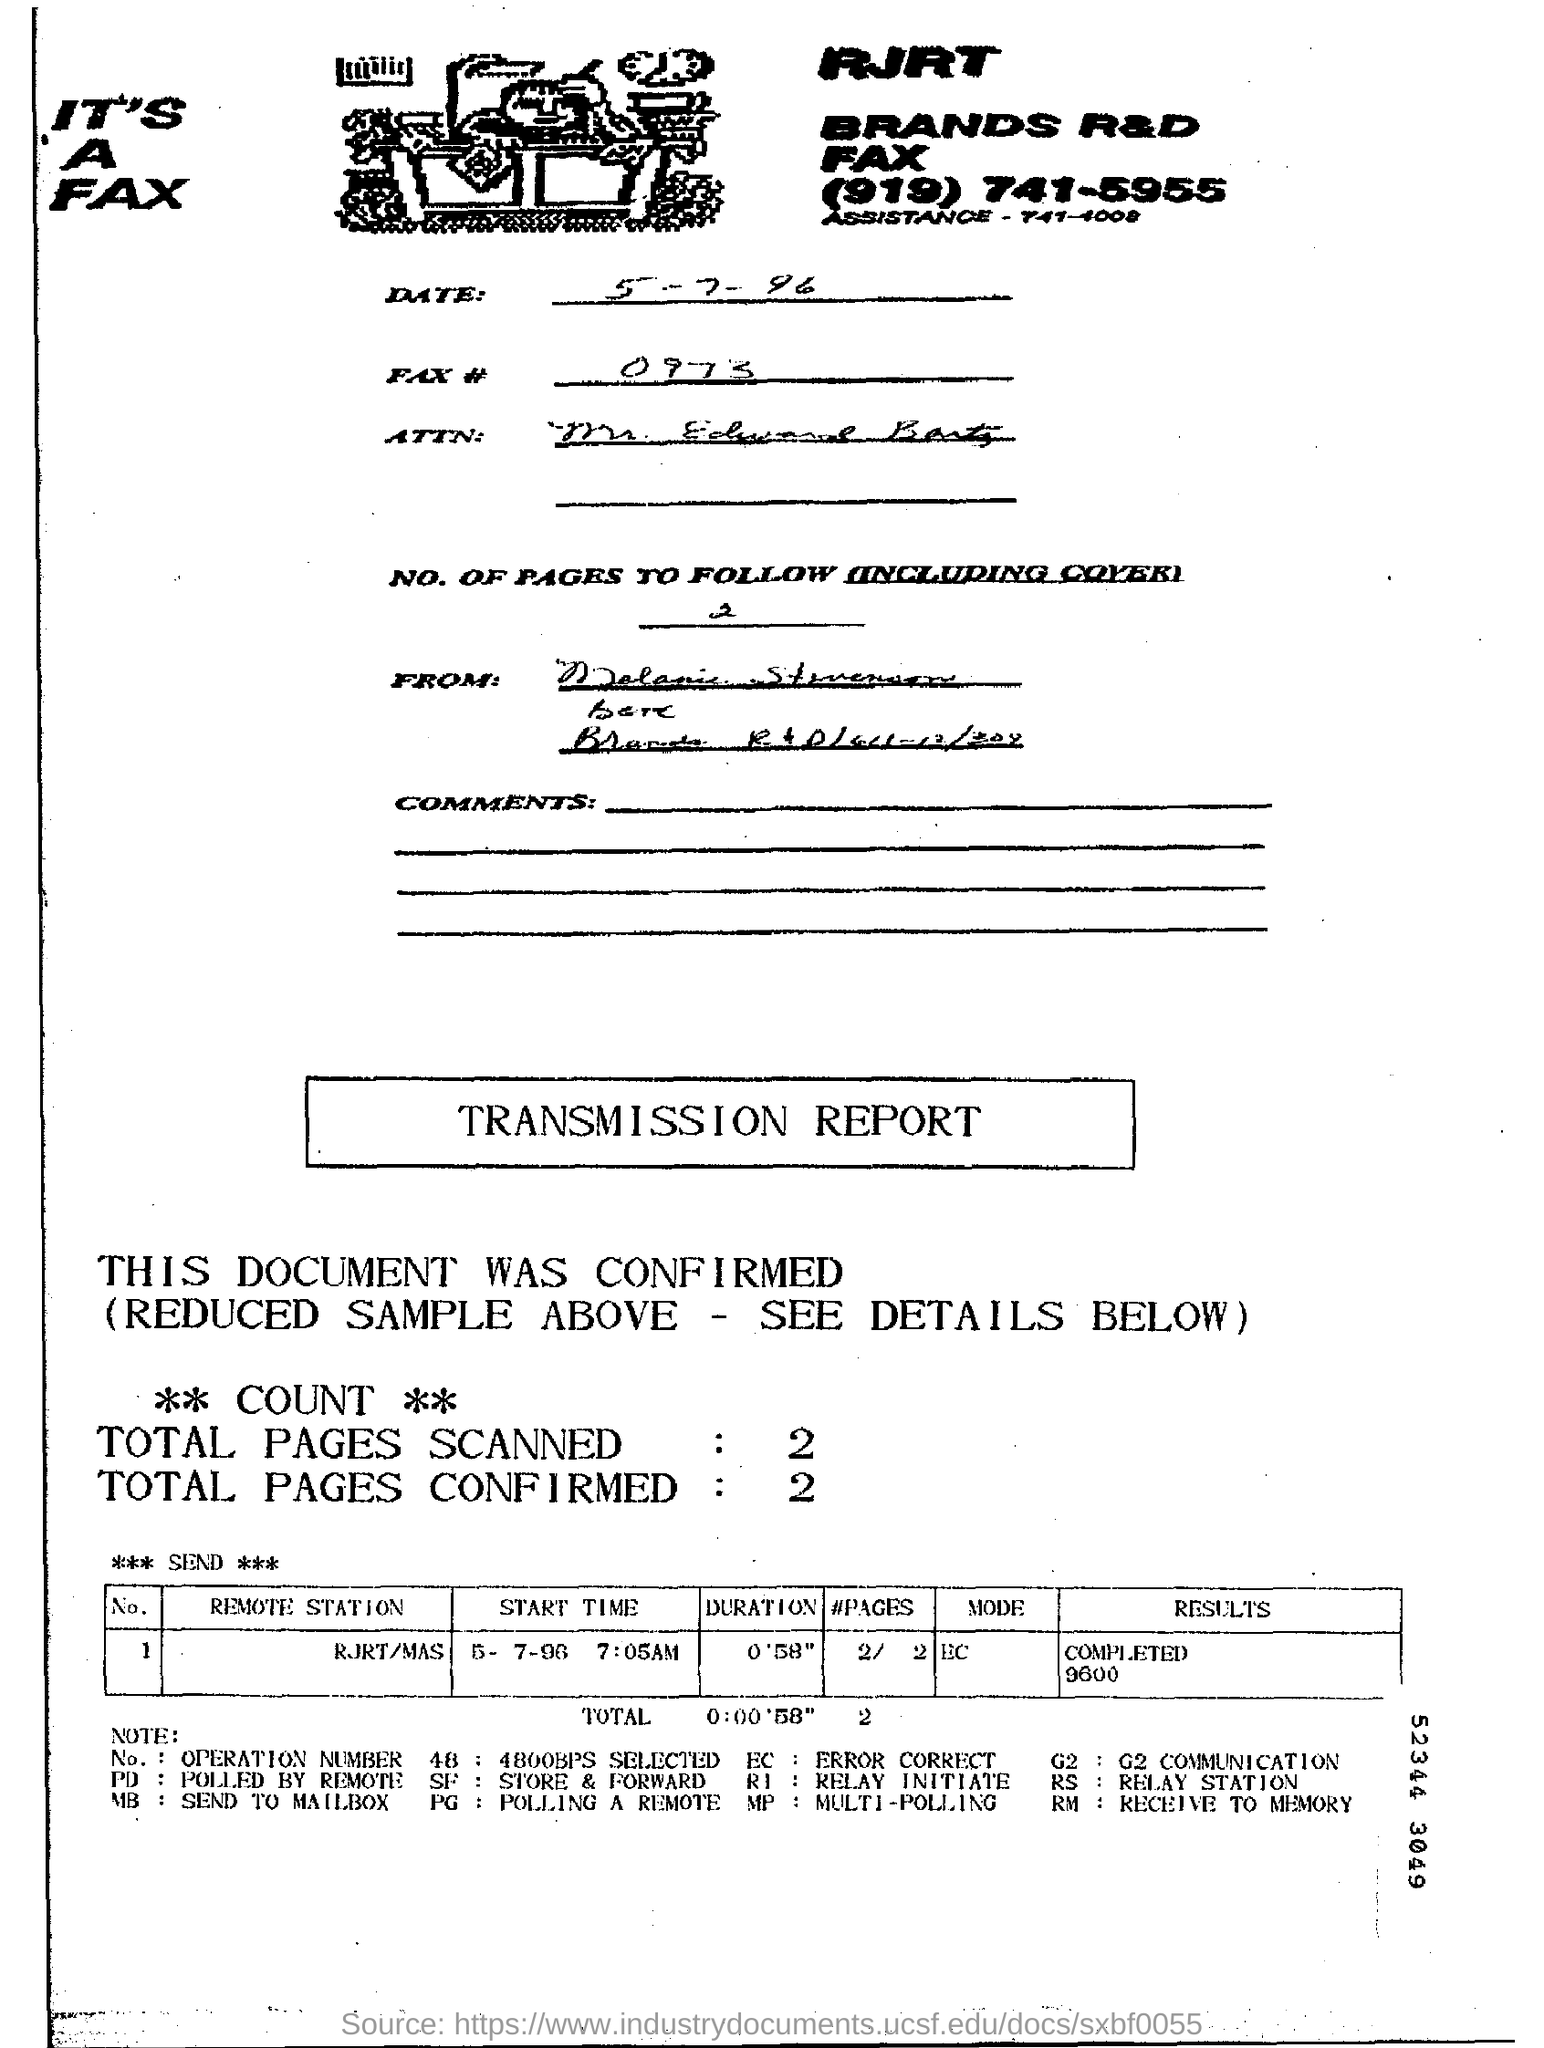How many total number of pages are scanned?
Offer a terse response. 2. How many total number of pages are confirmed?
Ensure brevity in your answer.  2. 